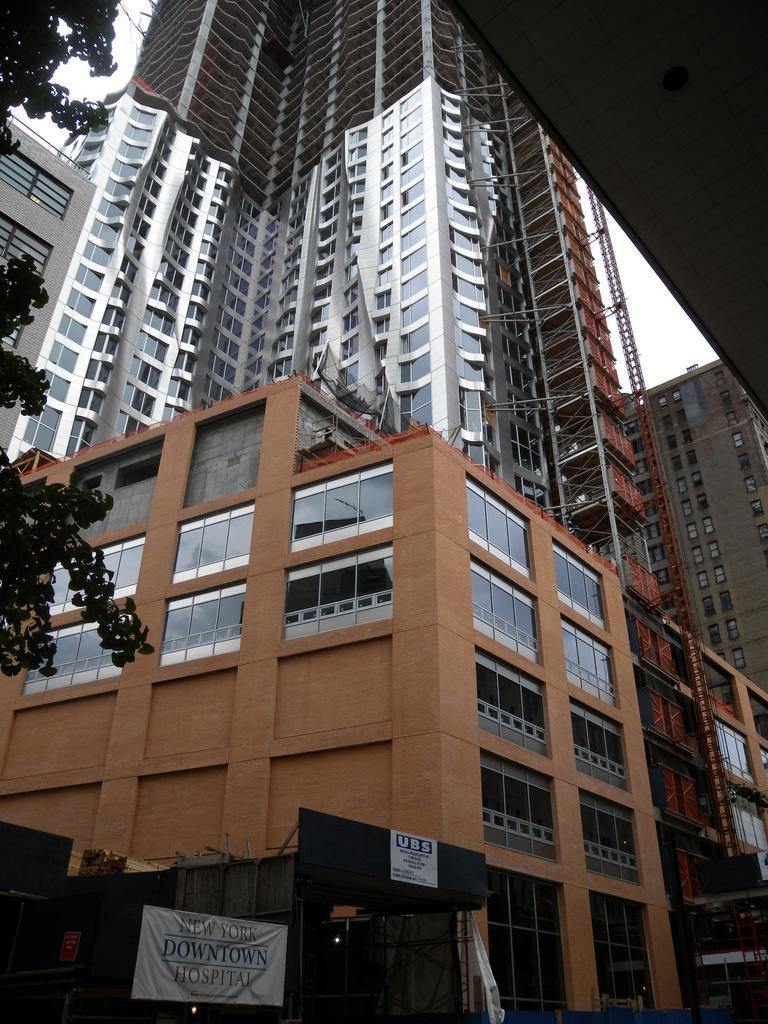Could you give a brief overview of what you see in this image? This picture shows a couple of buildings and a tree and we see couple of banners. 